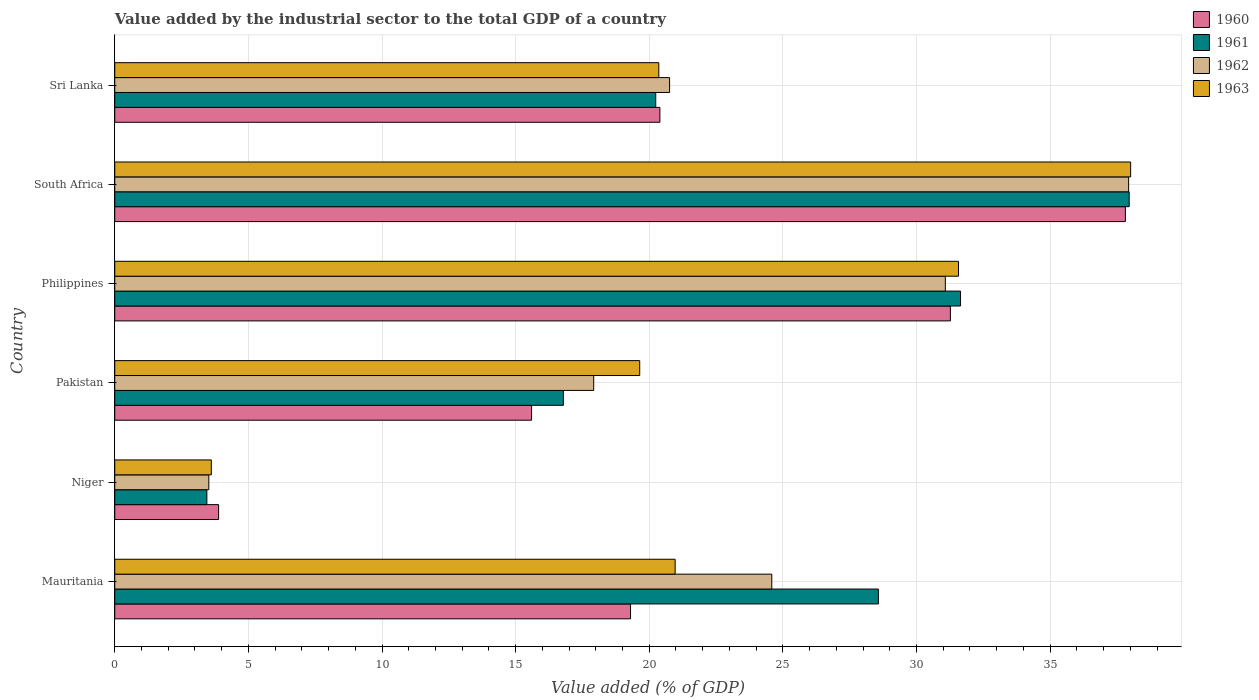How many different coloured bars are there?
Your response must be concise. 4. How many groups of bars are there?
Offer a terse response. 6. Are the number of bars on each tick of the Y-axis equal?
Offer a terse response. Yes. What is the label of the 2nd group of bars from the top?
Make the answer very short. South Africa. In how many cases, is the number of bars for a given country not equal to the number of legend labels?
Your answer should be compact. 0. What is the value added by the industrial sector to the total GDP in 1962 in Pakistan?
Provide a succinct answer. 17.92. Across all countries, what is the maximum value added by the industrial sector to the total GDP in 1963?
Offer a very short reply. 38.01. Across all countries, what is the minimum value added by the industrial sector to the total GDP in 1962?
Keep it short and to the point. 3.52. In which country was the value added by the industrial sector to the total GDP in 1960 maximum?
Offer a terse response. South Africa. In which country was the value added by the industrial sector to the total GDP in 1960 minimum?
Offer a very short reply. Niger. What is the total value added by the industrial sector to the total GDP in 1963 in the graph?
Give a very brief answer. 134.17. What is the difference between the value added by the industrial sector to the total GDP in 1963 in Mauritania and that in Philippines?
Offer a terse response. -10.6. What is the difference between the value added by the industrial sector to the total GDP in 1962 in Mauritania and the value added by the industrial sector to the total GDP in 1960 in Pakistan?
Your response must be concise. 8.99. What is the average value added by the industrial sector to the total GDP in 1961 per country?
Your answer should be compact. 23.11. What is the difference between the value added by the industrial sector to the total GDP in 1960 and value added by the industrial sector to the total GDP in 1962 in Mauritania?
Keep it short and to the point. -5.29. What is the ratio of the value added by the industrial sector to the total GDP in 1960 in Niger to that in South Africa?
Your answer should be compact. 0.1. Is the difference between the value added by the industrial sector to the total GDP in 1960 in Niger and Sri Lanka greater than the difference between the value added by the industrial sector to the total GDP in 1962 in Niger and Sri Lanka?
Provide a succinct answer. Yes. What is the difference between the highest and the second highest value added by the industrial sector to the total GDP in 1960?
Offer a very short reply. 6.55. What is the difference between the highest and the lowest value added by the industrial sector to the total GDP in 1960?
Your answer should be very brief. 33.93. What does the 1st bar from the top in Philippines represents?
Make the answer very short. 1963. What does the 2nd bar from the bottom in South Africa represents?
Ensure brevity in your answer.  1961. Is it the case that in every country, the sum of the value added by the industrial sector to the total GDP in 1960 and value added by the industrial sector to the total GDP in 1962 is greater than the value added by the industrial sector to the total GDP in 1961?
Offer a terse response. Yes. How many bars are there?
Make the answer very short. 24. What is the difference between two consecutive major ticks on the X-axis?
Provide a succinct answer. 5. Does the graph contain any zero values?
Give a very brief answer. No. Where does the legend appear in the graph?
Keep it short and to the point. Top right. How many legend labels are there?
Your answer should be compact. 4. How are the legend labels stacked?
Your answer should be very brief. Vertical. What is the title of the graph?
Offer a terse response. Value added by the industrial sector to the total GDP of a country. What is the label or title of the X-axis?
Your answer should be very brief. Value added (% of GDP). What is the label or title of the Y-axis?
Your response must be concise. Country. What is the Value added (% of GDP) of 1960 in Mauritania?
Provide a short and direct response. 19.3. What is the Value added (% of GDP) in 1961 in Mauritania?
Your answer should be compact. 28.57. What is the Value added (% of GDP) of 1962 in Mauritania?
Make the answer very short. 24.59. What is the Value added (% of GDP) in 1963 in Mauritania?
Keep it short and to the point. 20.97. What is the Value added (% of GDP) of 1960 in Niger?
Make the answer very short. 3.89. What is the Value added (% of GDP) of 1961 in Niger?
Provide a succinct answer. 3.45. What is the Value added (% of GDP) in 1962 in Niger?
Keep it short and to the point. 3.52. What is the Value added (% of GDP) in 1963 in Niger?
Ensure brevity in your answer.  3.61. What is the Value added (% of GDP) of 1960 in Pakistan?
Provide a short and direct response. 15.6. What is the Value added (% of GDP) in 1961 in Pakistan?
Your answer should be very brief. 16.79. What is the Value added (% of GDP) in 1962 in Pakistan?
Your answer should be very brief. 17.92. What is the Value added (% of GDP) of 1963 in Pakistan?
Your answer should be compact. 19.64. What is the Value added (% of GDP) of 1960 in Philippines?
Your answer should be compact. 31.27. What is the Value added (% of GDP) in 1961 in Philippines?
Provide a short and direct response. 31.65. What is the Value added (% of GDP) in 1962 in Philippines?
Your answer should be very brief. 31.08. What is the Value added (% of GDP) of 1963 in Philippines?
Your answer should be compact. 31.57. What is the Value added (% of GDP) in 1960 in South Africa?
Offer a terse response. 37.82. What is the Value added (% of GDP) of 1961 in South Africa?
Ensure brevity in your answer.  37.96. What is the Value added (% of GDP) in 1962 in South Africa?
Provide a short and direct response. 37.94. What is the Value added (% of GDP) in 1963 in South Africa?
Provide a short and direct response. 38.01. What is the Value added (% of GDP) of 1960 in Sri Lanka?
Ensure brevity in your answer.  20.4. What is the Value added (% of GDP) in 1961 in Sri Lanka?
Provide a succinct answer. 20.24. What is the Value added (% of GDP) of 1962 in Sri Lanka?
Your answer should be very brief. 20.76. What is the Value added (% of GDP) of 1963 in Sri Lanka?
Make the answer very short. 20.36. Across all countries, what is the maximum Value added (% of GDP) of 1960?
Offer a very short reply. 37.82. Across all countries, what is the maximum Value added (% of GDP) of 1961?
Keep it short and to the point. 37.96. Across all countries, what is the maximum Value added (% of GDP) in 1962?
Your answer should be very brief. 37.94. Across all countries, what is the maximum Value added (% of GDP) in 1963?
Provide a short and direct response. 38.01. Across all countries, what is the minimum Value added (% of GDP) of 1960?
Your response must be concise. 3.89. Across all countries, what is the minimum Value added (% of GDP) of 1961?
Your response must be concise. 3.45. Across all countries, what is the minimum Value added (% of GDP) in 1962?
Ensure brevity in your answer.  3.52. Across all countries, what is the minimum Value added (% of GDP) of 1963?
Your answer should be very brief. 3.61. What is the total Value added (% of GDP) in 1960 in the graph?
Offer a very short reply. 128.27. What is the total Value added (% of GDP) in 1961 in the graph?
Offer a very short reply. 138.66. What is the total Value added (% of GDP) in 1962 in the graph?
Offer a terse response. 135.81. What is the total Value added (% of GDP) in 1963 in the graph?
Your response must be concise. 134.17. What is the difference between the Value added (% of GDP) of 1960 in Mauritania and that in Niger?
Offer a terse response. 15.41. What is the difference between the Value added (% of GDP) in 1961 in Mauritania and that in Niger?
Provide a short and direct response. 25.13. What is the difference between the Value added (% of GDP) of 1962 in Mauritania and that in Niger?
Make the answer very short. 21.07. What is the difference between the Value added (% of GDP) of 1963 in Mauritania and that in Niger?
Make the answer very short. 17.36. What is the difference between the Value added (% of GDP) in 1960 in Mauritania and that in Pakistan?
Your answer should be compact. 3.7. What is the difference between the Value added (% of GDP) of 1961 in Mauritania and that in Pakistan?
Ensure brevity in your answer.  11.79. What is the difference between the Value added (% of GDP) of 1962 in Mauritania and that in Pakistan?
Your response must be concise. 6.66. What is the difference between the Value added (% of GDP) in 1963 in Mauritania and that in Pakistan?
Provide a succinct answer. 1.33. What is the difference between the Value added (% of GDP) in 1960 in Mauritania and that in Philippines?
Offer a very short reply. -11.97. What is the difference between the Value added (% of GDP) in 1961 in Mauritania and that in Philippines?
Give a very brief answer. -3.07. What is the difference between the Value added (% of GDP) in 1962 in Mauritania and that in Philippines?
Your answer should be very brief. -6.49. What is the difference between the Value added (% of GDP) of 1963 in Mauritania and that in Philippines?
Your response must be concise. -10.6. What is the difference between the Value added (% of GDP) of 1960 in Mauritania and that in South Africa?
Make the answer very short. -18.52. What is the difference between the Value added (% of GDP) in 1961 in Mauritania and that in South Africa?
Offer a very short reply. -9.38. What is the difference between the Value added (% of GDP) of 1962 in Mauritania and that in South Africa?
Your answer should be compact. -13.35. What is the difference between the Value added (% of GDP) in 1963 in Mauritania and that in South Africa?
Offer a very short reply. -17.04. What is the difference between the Value added (% of GDP) in 1960 in Mauritania and that in Sri Lanka?
Your answer should be compact. -1.1. What is the difference between the Value added (% of GDP) in 1961 in Mauritania and that in Sri Lanka?
Your answer should be compact. 8.33. What is the difference between the Value added (% of GDP) in 1962 in Mauritania and that in Sri Lanka?
Your answer should be compact. 3.82. What is the difference between the Value added (% of GDP) of 1963 in Mauritania and that in Sri Lanka?
Your response must be concise. 0.61. What is the difference between the Value added (% of GDP) in 1960 in Niger and that in Pakistan?
Ensure brevity in your answer.  -11.71. What is the difference between the Value added (% of GDP) of 1961 in Niger and that in Pakistan?
Offer a terse response. -13.34. What is the difference between the Value added (% of GDP) in 1962 in Niger and that in Pakistan?
Your answer should be very brief. -14.4. What is the difference between the Value added (% of GDP) in 1963 in Niger and that in Pakistan?
Give a very brief answer. -16.03. What is the difference between the Value added (% of GDP) in 1960 in Niger and that in Philippines?
Keep it short and to the point. -27.38. What is the difference between the Value added (% of GDP) in 1961 in Niger and that in Philippines?
Offer a very short reply. -28.2. What is the difference between the Value added (% of GDP) in 1962 in Niger and that in Philippines?
Offer a terse response. -27.56. What is the difference between the Value added (% of GDP) in 1963 in Niger and that in Philippines?
Make the answer very short. -27.96. What is the difference between the Value added (% of GDP) of 1960 in Niger and that in South Africa?
Provide a short and direct response. -33.93. What is the difference between the Value added (% of GDP) of 1961 in Niger and that in South Africa?
Make the answer very short. -34.51. What is the difference between the Value added (% of GDP) in 1962 in Niger and that in South Africa?
Ensure brevity in your answer.  -34.42. What is the difference between the Value added (% of GDP) of 1963 in Niger and that in South Africa?
Your answer should be very brief. -34.4. What is the difference between the Value added (% of GDP) in 1960 in Niger and that in Sri Lanka?
Offer a very short reply. -16.51. What is the difference between the Value added (% of GDP) in 1961 in Niger and that in Sri Lanka?
Ensure brevity in your answer.  -16.8. What is the difference between the Value added (% of GDP) of 1962 in Niger and that in Sri Lanka?
Offer a terse response. -17.24. What is the difference between the Value added (% of GDP) in 1963 in Niger and that in Sri Lanka?
Offer a terse response. -16.74. What is the difference between the Value added (% of GDP) of 1960 in Pakistan and that in Philippines?
Your response must be concise. -15.67. What is the difference between the Value added (% of GDP) of 1961 in Pakistan and that in Philippines?
Provide a short and direct response. -14.86. What is the difference between the Value added (% of GDP) of 1962 in Pakistan and that in Philippines?
Make the answer very short. -13.16. What is the difference between the Value added (% of GDP) in 1963 in Pakistan and that in Philippines?
Ensure brevity in your answer.  -11.93. What is the difference between the Value added (% of GDP) of 1960 in Pakistan and that in South Africa?
Provide a short and direct response. -22.22. What is the difference between the Value added (% of GDP) of 1961 in Pakistan and that in South Africa?
Your response must be concise. -21.17. What is the difference between the Value added (% of GDP) in 1962 in Pakistan and that in South Africa?
Make the answer very short. -20.02. What is the difference between the Value added (% of GDP) in 1963 in Pakistan and that in South Africa?
Your answer should be very brief. -18.37. What is the difference between the Value added (% of GDP) of 1960 in Pakistan and that in Sri Lanka?
Provide a short and direct response. -4.8. What is the difference between the Value added (% of GDP) in 1961 in Pakistan and that in Sri Lanka?
Offer a terse response. -3.46. What is the difference between the Value added (% of GDP) in 1962 in Pakistan and that in Sri Lanka?
Make the answer very short. -2.84. What is the difference between the Value added (% of GDP) of 1963 in Pakistan and that in Sri Lanka?
Your answer should be very brief. -0.71. What is the difference between the Value added (% of GDP) in 1960 in Philippines and that in South Africa?
Provide a succinct answer. -6.55. What is the difference between the Value added (% of GDP) of 1961 in Philippines and that in South Africa?
Your answer should be very brief. -6.31. What is the difference between the Value added (% of GDP) of 1962 in Philippines and that in South Africa?
Give a very brief answer. -6.86. What is the difference between the Value added (% of GDP) of 1963 in Philippines and that in South Africa?
Provide a short and direct response. -6.44. What is the difference between the Value added (% of GDP) of 1960 in Philippines and that in Sri Lanka?
Keep it short and to the point. 10.87. What is the difference between the Value added (% of GDP) in 1961 in Philippines and that in Sri Lanka?
Give a very brief answer. 11.41. What is the difference between the Value added (% of GDP) in 1962 in Philippines and that in Sri Lanka?
Offer a very short reply. 10.32. What is the difference between the Value added (% of GDP) of 1963 in Philippines and that in Sri Lanka?
Make the answer very short. 11.22. What is the difference between the Value added (% of GDP) of 1960 in South Africa and that in Sri Lanka?
Make the answer very short. 17.42. What is the difference between the Value added (% of GDP) in 1961 in South Africa and that in Sri Lanka?
Provide a succinct answer. 17.72. What is the difference between the Value added (% of GDP) of 1962 in South Africa and that in Sri Lanka?
Your answer should be very brief. 17.18. What is the difference between the Value added (% of GDP) in 1963 in South Africa and that in Sri Lanka?
Your response must be concise. 17.66. What is the difference between the Value added (% of GDP) in 1960 in Mauritania and the Value added (% of GDP) in 1961 in Niger?
Give a very brief answer. 15.85. What is the difference between the Value added (% of GDP) of 1960 in Mauritania and the Value added (% of GDP) of 1962 in Niger?
Offer a terse response. 15.78. What is the difference between the Value added (% of GDP) in 1960 in Mauritania and the Value added (% of GDP) in 1963 in Niger?
Your answer should be compact. 15.69. What is the difference between the Value added (% of GDP) of 1961 in Mauritania and the Value added (% of GDP) of 1962 in Niger?
Keep it short and to the point. 25.05. What is the difference between the Value added (% of GDP) of 1961 in Mauritania and the Value added (% of GDP) of 1963 in Niger?
Give a very brief answer. 24.96. What is the difference between the Value added (% of GDP) in 1962 in Mauritania and the Value added (% of GDP) in 1963 in Niger?
Your answer should be compact. 20.97. What is the difference between the Value added (% of GDP) in 1960 in Mauritania and the Value added (% of GDP) in 1961 in Pakistan?
Your response must be concise. 2.51. What is the difference between the Value added (% of GDP) in 1960 in Mauritania and the Value added (% of GDP) in 1962 in Pakistan?
Offer a terse response. 1.38. What is the difference between the Value added (% of GDP) of 1960 in Mauritania and the Value added (% of GDP) of 1963 in Pakistan?
Make the answer very short. -0.34. What is the difference between the Value added (% of GDP) of 1961 in Mauritania and the Value added (% of GDP) of 1962 in Pakistan?
Your answer should be very brief. 10.65. What is the difference between the Value added (% of GDP) in 1961 in Mauritania and the Value added (% of GDP) in 1963 in Pakistan?
Your answer should be compact. 8.93. What is the difference between the Value added (% of GDP) in 1962 in Mauritania and the Value added (% of GDP) in 1963 in Pakistan?
Your response must be concise. 4.94. What is the difference between the Value added (% of GDP) in 1960 in Mauritania and the Value added (% of GDP) in 1961 in Philippines?
Give a very brief answer. -12.35. What is the difference between the Value added (% of GDP) in 1960 in Mauritania and the Value added (% of GDP) in 1962 in Philippines?
Provide a succinct answer. -11.78. What is the difference between the Value added (% of GDP) of 1960 in Mauritania and the Value added (% of GDP) of 1963 in Philippines?
Make the answer very short. -12.27. What is the difference between the Value added (% of GDP) of 1961 in Mauritania and the Value added (% of GDP) of 1962 in Philippines?
Give a very brief answer. -2.51. What is the difference between the Value added (% of GDP) in 1961 in Mauritania and the Value added (% of GDP) in 1963 in Philippines?
Make the answer very short. -3. What is the difference between the Value added (% of GDP) in 1962 in Mauritania and the Value added (% of GDP) in 1963 in Philippines?
Your response must be concise. -6.99. What is the difference between the Value added (% of GDP) of 1960 in Mauritania and the Value added (% of GDP) of 1961 in South Africa?
Provide a succinct answer. -18.66. What is the difference between the Value added (% of GDP) in 1960 in Mauritania and the Value added (% of GDP) in 1962 in South Africa?
Your response must be concise. -18.64. What is the difference between the Value added (% of GDP) of 1960 in Mauritania and the Value added (% of GDP) of 1963 in South Africa?
Give a very brief answer. -18.71. What is the difference between the Value added (% of GDP) of 1961 in Mauritania and the Value added (% of GDP) of 1962 in South Africa?
Offer a very short reply. -9.36. What is the difference between the Value added (% of GDP) of 1961 in Mauritania and the Value added (% of GDP) of 1963 in South Africa?
Offer a terse response. -9.44. What is the difference between the Value added (% of GDP) in 1962 in Mauritania and the Value added (% of GDP) in 1963 in South Africa?
Your answer should be very brief. -13.43. What is the difference between the Value added (% of GDP) of 1960 in Mauritania and the Value added (% of GDP) of 1961 in Sri Lanka?
Your response must be concise. -0.94. What is the difference between the Value added (% of GDP) of 1960 in Mauritania and the Value added (% of GDP) of 1962 in Sri Lanka?
Make the answer very short. -1.46. What is the difference between the Value added (% of GDP) in 1960 in Mauritania and the Value added (% of GDP) in 1963 in Sri Lanka?
Give a very brief answer. -1.06. What is the difference between the Value added (% of GDP) in 1961 in Mauritania and the Value added (% of GDP) in 1962 in Sri Lanka?
Your response must be concise. 7.81. What is the difference between the Value added (% of GDP) of 1961 in Mauritania and the Value added (% of GDP) of 1963 in Sri Lanka?
Your response must be concise. 8.22. What is the difference between the Value added (% of GDP) in 1962 in Mauritania and the Value added (% of GDP) in 1963 in Sri Lanka?
Give a very brief answer. 4.23. What is the difference between the Value added (% of GDP) in 1960 in Niger and the Value added (% of GDP) in 1961 in Pakistan?
Keep it short and to the point. -12.9. What is the difference between the Value added (% of GDP) of 1960 in Niger and the Value added (% of GDP) of 1962 in Pakistan?
Your answer should be very brief. -14.04. What is the difference between the Value added (% of GDP) in 1960 in Niger and the Value added (% of GDP) in 1963 in Pakistan?
Give a very brief answer. -15.76. What is the difference between the Value added (% of GDP) in 1961 in Niger and the Value added (% of GDP) in 1962 in Pakistan?
Provide a short and direct response. -14.48. What is the difference between the Value added (% of GDP) in 1961 in Niger and the Value added (% of GDP) in 1963 in Pakistan?
Ensure brevity in your answer.  -16.2. What is the difference between the Value added (% of GDP) in 1962 in Niger and the Value added (% of GDP) in 1963 in Pakistan?
Offer a very short reply. -16.12. What is the difference between the Value added (% of GDP) of 1960 in Niger and the Value added (% of GDP) of 1961 in Philippines?
Your response must be concise. -27.76. What is the difference between the Value added (% of GDP) in 1960 in Niger and the Value added (% of GDP) in 1962 in Philippines?
Give a very brief answer. -27.19. What is the difference between the Value added (% of GDP) of 1960 in Niger and the Value added (% of GDP) of 1963 in Philippines?
Ensure brevity in your answer.  -27.69. What is the difference between the Value added (% of GDP) in 1961 in Niger and the Value added (% of GDP) in 1962 in Philippines?
Your answer should be very brief. -27.63. What is the difference between the Value added (% of GDP) in 1961 in Niger and the Value added (% of GDP) in 1963 in Philippines?
Offer a terse response. -28.13. What is the difference between the Value added (% of GDP) of 1962 in Niger and the Value added (% of GDP) of 1963 in Philippines?
Ensure brevity in your answer.  -28.05. What is the difference between the Value added (% of GDP) of 1960 in Niger and the Value added (% of GDP) of 1961 in South Africa?
Give a very brief answer. -34.07. What is the difference between the Value added (% of GDP) of 1960 in Niger and the Value added (% of GDP) of 1962 in South Africa?
Offer a terse response. -34.05. What is the difference between the Value added (% of GDP) in 1960 in Niger and the Value added (% of GDP) in 1963 in South Africa?
Provide a short and direct response. -34.13. What is the difference between the Value added (% of GDP) in 1961 in Niger and the Value added (% of GDP) in 1962 in South Africa?
Provide a short and direct response. -34.49. What is the difference between the Value added (% of GDP) of 1961 in Niger and the Value added (% of GDP) of 1963 in South Africa?
Offer a very short reply. -34.57. What is the difference between the Value added (% of GDP) in 1962 in Niger and the Value added (% of GDP) in 1963 in South Africa?
Keep it short and to the point. -34.49. What is the difference between the Value added (% of GDP) in 1960 in Niger and the Value added (% of GDP) in 1961 in Sri Lanka?
Ensure brevity in your answer.  -16.36. What is the difference between the Value added (% of GDP) in 1960 in Niger and the Value added (% of GDP) in 1962 in Sri Lanka?
Keep it short and to the point. -16.88. What is the difference between the Value added (% of GDP) of 1960 in Niger and the Value added (% of GDP) of 1963 in Sri Lanka?
Ensure brevity in your answer.  -16.47. What is the difference between the Value added (% of GDP) of 1961 in Niger and the Value added (% of GDP) of 1962 in Sri Lanka?
Keep it short and to the point. -17.32. What is the difference between the Value added (% of GDP) of 1961 in Niger and the Value added (% of GDP) of 1963 in Sri Lanka?
Offer a very short reply. -16.91. What is the difference between the Value added (% of GDP) of 1962 in Niger and the Value added (% of GDP) of 1963 in Sri Lanka?
Your response must be concise. -16.84. What is the difference between the Value added (% of GDP) of 1960 in Pakistan and the Value added (% of GDP) of 1961 in Philippines?
Provide a succinct answer. -16.05. What is the difference between the Value added (% of GDP) of 1960 in Pakistan and the Value added (% of GDP) of 1962 in Philippines?
Provide a succinct answer. -15.48. What is the difference between the Value added (% of GDP) of 1960 in Pakistan and the Value added (% of GDP) of 1963 in Philippines?
Give a very brief answer. -15.98. What is the difference between the Value added (% of GDP) of 1961 in Pakistan and the Value added (% of GDP) of 1962 in Philippines?
Offer a very short reply. -14.29. What is the difference between the Value added (% of GDP) in 1961 in Pakistan and the Value added (% of GDP) in 1963 in Philippines?
Provide a short and direct response. -14.79. What is the difference between the Value added (% of GDP) of 1962 in Pakistan and the Value added (% of GDP) of 1963 in Philippines?
Make the answer very short. -13.65. What is the difference between the Value added (% of GDP) of 1960 in Pakistan and the Value added (% of GDP) of 1961 in South Africa?
Make the answer very short. -22.36. What is the difference between the Value added (% of GDP) of 1960 in Pakistan and the Value added (% of GDP) of 1962 in South Africa?
Make the answer very short. -22.34. What is the difference between the Value added (% of GDP) of 1960 in Pakistan and the Value added (% of GDP) of 1963 in South Africa?
Offer a terse response. -22.42. What is the difference between the Value added (% of GDP) in 1961 in Pakistan and the Value added (% of GDP) in 1962 in South Africa?
Provide a short and direct response. -21.15. What is the difference between the Value added (% of GDP) in 1961 in Pakistan and the Value added (% of GDP) in 1963 in South Africa?
Your answer should be very brief. -21.23. What is the difference between the Value added (% of GDP) in 1962 in Pakistan and the Value added (% of GDP) in 1963 in South Africa?
Your answer should be very brief. -20.09. What is the difference between the Value added (% of GDP) of 1960 in Pakistan and the Value added (% of GDP) of 1961 in Sri Lanka?
Keep it short and to the point. -4.65. What is the difference between the Value added (% of GDP) in 1960 in Pakistan and the Value added (% of GDP) in 1962 in Sri Lanka?
Your answer should be compact. -5.16. What is the difference between the Value added (% of GDP) of 1960 in Pakistan and the Value added (% of GDP) of 1963 in Sri Lanka?
Your answer should be very brief. -4.76. What is the difference between the Value added (% of GDP) in 1961 in Pakistan and the Value added (% of GDP) in 1962 in Sri Lanka?
Keep it short and to the point. -3.97. What is the difference between the Value added (% of GDP) in 1961 in Pakistan and the Value added (% of GDP) in 1963 in Sri Lanka?
Make the answer very short. -3.57. What is the difference between the Value added (% of GDP) of 1962 in Pakistan and the Value added (% of GDP) of 1963 in Sri Lanka?
Your answer should be very brief. -2.44. What is the difference between the Value added (% of GDP) in 1960 in Philippines and the Value added (% of GDP) in 1961 in South Africa?
Provide a succinct answer. -6.69. What is the difference between the Value added (% of GDP) in 1960 in Philippines and the Value added (% of GDP) in 1962 in South Africa?
Offer a terse response. -6.67. What is the difference between the Value added (% of GDP) in 1960 in Philippines and the Value added (% of GDP) in 1963 in South Africa?
Your answer should be compact. -6.75. What is the difference between the Value added (% of GDP) of 1961 in Philippines and the Value added (% of GDP) of 1962 in South Africa?
Your response must be concise. -6.29. What is the difference between the Value added (% of GDP) in 1961 in Philippines and the Value added (% of GDP) in 1963 in South Africa?
Your answer should be very brief. -6.37. What is the difference between the Value added (% of GDP) of 1962 in Philippines and the Value added (% of GDP) of 1963 in South Africa?
Your response must be concise. -6.93. What is the difference between the Value added (% of GDP) of 1960 in Philippines and the Value added (% of GDP) of 1961 in Sri Lanka?
Your answer should be compact. 11.03. What is the difference between the Value added (% of GDP) of 1960 in Philippines and the Value added (% of GDP) of 1962 in Sri Lanka?
Give a very brief answer. 10.51. What is the difference between the Value added (% of GDP) of 1960 in Philippines and the Value added (% of GDP) of 1963 in Sri Lanka?
Offer a very short reply. 10.91. What is the difference between the Value added (% of GDP) in 1961 in Philippines and the Value added (% of GDP) in 1962 in Sri Lanka?
Your response must be concise. 10.89. What is the difference between the Value added (% of GDP) of 1961 in Philippines and the Value added (% of GDP) of 1963 in Sri Lanka?
Offer a very short reply. 11.29. What is the difference between the Value added (% of GDP) of 1962 in Philippines and the Value added (% of GDP) of 1963 in Sri Lanka?
Your answer should be compact. 10.72. What is the difference between the Value added (% of GDP) of 1960 in South Africa and the Value added (% of GDP) of 1961 in Sri Lanka?
Provide a short and direct response. 17.57. What is the difference between the Value added (% of GDP) of 1960 in South Africa and the Value added (% of GDP) of 1962 in Sri Lanka?
Offer a terse response. 17.06. What is the difference between the Value added (% of GDP) of 1960 in South Africa and the Value added (% of GDP) of 1963 in Sri Lanka?
Your response must be concise. 17.46. What is the difference between the Value added (% of GDP) of 1961 in South Africa and the Value added (% of GDP) of 1962 in Sri Lanka?
Give a very brief answer. 17.2. What is the difference between the Value added (% of GDP) of 1961 in South Africa and the Value added (% of GDP) of 1963 in Sri Lanka?
Keep it short and to the point. 17.6. What is the difference between the Value added (% of GDP) of 1962 in South Africa and the Value added (% of GDP) of 1963 in Sri Lanka?
Provide a succinct answer. 17.58. What is the average Value added (% of GDP) in 1960 per country?
Provide a succinct answer. 21.38. What is the average Value added (% of GDP) in 1961 per country?
Offer a terse response. 23.11. What is the average Value added (% of GDP) of 1962 per country?
Provide a succinct answer. 22.63. What is the average Value added (% of GDP) in 1963 per country?
Give a very brief answer. 22.36. What is the difference between the Value added (% of GDP) of 1960 and Value added (% of GDP) of 1961 in Mauritania?
Ensure brevity in your answer.  -9.27. What is the difference between the Value added (% of GDP) of 1960 and Value added (% of GDP) of 1962 in Mauritania?
Offer a terse response. -5.29. What is the difference between the Value added (% of GDP) in 1960 and Value added (% of GDP) in 1963 in Mauritania?
Ensure brevity in your answer.  -1.67. What is the difference between the Value added (% of GDP) of 1961 and Value added (% of GDP) of 1962 in Mauritania?
Make the answer very short. 3.99. What is the difference between the Value added (% of GDP) in 1961 and Value added (% of GDP) in 1963 in Mauritania?
Give a very brief answer. 7.6. What is the difference between the Value added (% of GDP) of 1962 and Value added (% of GDP) of 1963 in Mauritania?
Provide a succinct answer. 3.62. What is the difference between the Value added (% of GDP) of 1960 and Value added (% of GDP) of 1961 in Niger?
Your response must be concise. 0.44. What is the difference between the Value added (% of GDP) in 1960 and Value added (% of GDP) in 1962 in Niger?
Make the answer very short. 0.37. What is the difference between the Value added (% of GDP) in 1960 and Value added (% of GDP) in 1963 in Niger?
Your response must be concise. 0.27. What is the difference between the Value added (% of GDP) of 1961 and Value added (% of GDP) of 1962 in Niger?
Provide a succinct answer. -0.07. What is the difference between the Value added (% of GDP) in 1961 and Value added (% of GDP) in 1963 in Niger?
Provide a short and direct response. -0.17. What is the difference between the Value added (% of GDP) of 1962 and Value added (% of GDP) of 1963 in Niger?
Your answer should be very brief. -0.09. What is the difference between the Value added (% of GDP) in 1960 and Value added (% of GDP) in 1961 in Pakistan?
Give a very brief answer. -1.19. What is the difference between the Value added (% of GDP) in 1960 and Value added (% of GDP) in 1962 in Pakistan?
Ensure brevity in your answer.  -2.33. What is the difference between the Value added (% of GDP) of 1960 and Value added (% of GDP) of 1963 in Pakistan?
Ensure brevity in your answer.  -4.05. What is the difference between the Value added (% of GDP) of 1961 and Value added (% of GDP) of 1962 in Pakistan?
Offer a terse response. -1.14. What is the difference between the Value added (% of GDP) of 1961 and Value added (% of GDP) of 1963 in Pakistan?
Your answer should be compact. -2.86. What is the difference between the Value added (% of GDP) in 1962 and Value added (% of GDP) in 1963 in Pakistan?
Provide a short and direct response. -1.72. What is the difference between the Value added (% of GDP) of 1960 and Value added (% of GDP) of 1961 in Philippines?
Provide a short and direct response. -0.38. What is the difference between the Value added (% of GDP) in 1960 and Value added (% of GDP) in 1962 in Philippines?
Provide a succinct answer. 0.19. What is the difference between the Value added (% of GDP) of 1960 and Value added (% of GDP) of 1963 in Philippines?
Offer a terse response. -0.3. What is the difference between the Value added (% of GDP) in 1961 and Value added (% of GDP) in 1962 in Philippines?
Make the answer very short. 0.57. What is the difference between the Value added (% of GDP) in 1961 and Value added (% of GDP) in 1963 in Philippines?
Your answer should be very brief. 0.08. What is the difference between the Value added (% of GDP) of 1962 and Value added (% of GDP) of 1963 in Philippines?
Ensure brevity in your answer.  -0.49. What is the difference between the Value added (% of GDP) in 1960 and Value added (% of GDP) in 1961 in South Africa?
Provide a short and direct response. -0.14. What is the difference between the Value added (% of GDP) in 1960 and Value added (% of GDP) in 1962 in South Africa?
Make the answer very short. -0.12. What is the difference between the Value added (% of GDP) of 1960 and Value added (% of GDP) of 1963 in South Africa?
Your response must be concise. -0.2. What is the difference between the Value added (% of GDP) in 1961 and Value added (% of GDP) in 1962 in South Africa?
Keep it short and to the point. 0.02. What is the difference between the Value added (% of GDP) in 1961 and Value added (% of GDP) in 1963 in South Africa?
Keep it short and to the point. -0.05. What is the difference between the Value added (% of GDP) of 1962 and Value added (% of GDP) of 1963 in South Africa?
Your answer should be very brief. -0.08. What is the difference between the Value added (% of GDP) of 1960 and Value added (% of GDP) of 1961 in Sri Lanka?
Keep it short and to the point. 0.16. What is the difference between the Value added (% of GDP) of 1960 and Value added (% of GDP) of 1962 in Sri Lanka?
Offer a very short reply. -0.36. What is the difference between the Value added (% of GDP) of 1960 and Value added (% of GDP) of 1963 in Sri Lanka?
Your answer should be very brief. 0.04. What is the difference between the Value added (% of GDP) in 1961 and Value added (% of GDP) in 1962 in Sri Lanka?
Keep it short and to the point. -0.52. What is the difference between the Value added (% of GDP) in 1961 and Value added (% of GDP) in 1963 in Sri Lanka?
Your answer should be very brief. -0.11. What is the difference between the Value added (% of GDP) of 1962 and Value added (% of GDP) of 1963 in Sri Lanka?
Offer a terse response. 0.4. What is the ratio of the Value added (% of GDP) in 1960 in Mauritania to that in Niger?
Make the answer very short. 4.97. What is the ratio of the Value added (% of GDP) of 1961 in Mauritania to that in Niger?
Provide a short and direct response. 8.29. What is the ratio of the Value added (% of GDP) in 1962 in Mauritania to that in Niger?
Make the answer very short. 6.99. What is the ratio of the Value added (% of GDP) in 1963 in Mauritania to that in Niger?
Provide a succinct answer. 5.8. What is the ratio of the Value added (% of GDP) of 1960 in Mauritania to that in Pakistan?
Offer a terse response. 1.24. What is the ratio of the Value added (% of GDP) of 1961 in Mauritania to that in Pakistan?
Give a very brief answer. 1.7. What is the ratio of the Value added (% of GDP) of 1962 in Mauritania to that in Pakistan?
Give a very brief answer. 1.37. What is the ratio of the Value added (% of GDP) of 1963 in Mauritania to that in Pakistan?
Give a very brief answer. 1.07. What is the ratio of the Value added (% of GDP) in 1960 in Mauritania to that in Philippines?
Ensure brevity in your answer.  0.62. What is the ratio of the Value added (% of GDP) in 1961 in Mauritania to that in Philippines?
Offer a very short reply. 0.9. What is the ratio of the Value added (% of GDP) in 1962 in Mauritania to that in Philippines?
Your answer should be compact. 0.79. What is the ratio of the Value added (% of GDP) in 1963 in Mauritania to that in Philippines?
Keep it short and to the point. 0.66. What is the ratio of the Value added (% of GDP) in 1960 in Mauritania to that in South Africa?
Provide a short and direct response. 0.51. What is the ratio of the Value added (% of GDP) in 1961 in Mauritania to that in South Africa?
Provide a short and direct response. 0.75. What is the ratio of the Value added (% of GDP) in 1962 in Mauritania to that in South Africa?
Your response must be concise. 0.65. What is the ratio of the Value added (% of GDP) of 1963 in Mauritania to that in South Africa?
Keep it short and to the point. 0.55. What is the ratio of the Value added (% of GDP) in 1960 in Mauritania to that in Sri Lanka?
Give a very brief answer. 0.95. What is the ratio of the Value added (% of GDP) of 1961 in Mauritania to that in Sri Lanka?
Provide a short and direct response. 1.41. What is the ratio of the Value added (% of GDP) in 1962 in Mauritania to that in Sri Lanka?
Your answer should be very brief. 1.18. What is the ratio of the Value added (% of GDP) in 1963 in Mauritania to that in Sri Lanka?
Offer a terse response. 1.03. What is the ratio of the Value added (% of GDP) of 1960 in Niger to that in Pakistan?
Provide a succinct answer. 0.25. What is the ratio of the Value added (% of GDP) in 1961 in Niger to that in Pakistan?
Provide a short and direct response. 0.21. What is the ratio of the Value added (% of GDP) in 1962 in Niger to that in Pakistan?
Ensure brevity in your answer.  0.2. What is the ratio of the Value added (% of GDP) of 1963 in Niger to that in Pakistan?
Your answer should be very brief. 0.18. What is the ratio of the Value added (% of GDP) of 1960 in Niger to that in Philippines?
Offer a very short reply. 0.12. What is the ratio of the Value added (% of GDP) in 1961 in Niger to that in Philippines?
Offer a very short reply. 0.11. What is the ratio of the Value added (% of GDP) in 1962 in Niger to that in Philippines?
Ensure brevity in your answer.  0.11. What is the ratio of the Value added (% of GDP) of 1963 in Niger to that in Philippines?
Offer a terse response. 0.11. What is the ratio of the Value added (% of GDP) of 1960 in Niger to that in South Africa?
Keep it short and to the point. 0.1. What is the ratio of the Value added (% of GDP) of 1961 in Niger to that in South Africa?
Provide a succinct answer. 0.09. What is the ratio of the Value added (% of GDP) of 1962 in Niger to that in South Africa?
Provide a short and direct response. 0.09. What is the ratio of the Value added (% of GDP) in 1963 in Niger to that in South Africa?
Offer a very short reply. 0.1. What is the ratio of the Value added (% of GDP) in 1960 in Niger to that in Sri Lanka?
Give a very brief answer. 0.19. What is the ratio of the Value added (% of GDP) in 1961 in Niger to that in Sri Lanka?
Keep it short and to the point. 0.17. What is the ratio of the Value added (% of GDP) in 1962 in Niger to that in Sri Lanka?
Provide a short and direct response. 0.17. What is the ratio of the Value added (% of GDP) of 1963 in Niger to that in Sri Lanka?
Give a very brief answer. 0.18. What is the ratio of the Value added (% of GDP) of 1960 in Pakistan to that in Philippines?
Ensure brevity in your answer.  0.5. What is the ratio of the Value added (% of GDP) of 1961 in Pakistan to that in Philippines?
Give a very brief answer. 0.53. What is the ratio of the Value added (% of GDP) of 1962 in Pakistan to that in Philippines?
Your response must be concise. 0.58. What is the ratio of the Value added (% of GDP) in 1963 in Pakistan to that in Philippines?
Give a very brief answer. 0.62. What is the ratio of the Value added (% of GDP) of 1960 in Pakistan to that in South Africa?
Ensure brevity in your answer.  0.41. What is the ratio of the Value added (% of GDP) of 1961 in Pakistan to that in South Africa?
Offer a very short reply. 0.44. What is the ratio of the Value added (% of GDP) in 1962 in Pakistan to that in South Africa?
Ensure brevity in your answer.  0.47. What is the ratio of the Value added (% of GDP) of 1963 in Pakistan to that in South Africa?
Provide a succinct answer. 0.52. What is the ratio of the Value added (% of GDP) in 1960 in Pakistan to that in Sri Lanka?
Your answer should be very brief. 0.76. What is the ratio of the Value added (% of GDP) in 1961 in Pakistan to that in Sri Lanka?
Offer a terse response. 0.83. What is the ratio of the Value added (% of GDP) of 1962 in Pakistan to that in Sri Lanka?
Provide a succinct answer. 0.86. What is the ratio of the Value added (% of GDP) in 1963 in Pakistan to that in Sri Lanka?
Offer a very short reply. 0.96. What is the ratio of the Value added (% of GDP) of 1960 in Philippines to that in South Africa?
Your answer should be very brief. 0.83. What is the ratio of the Value added (% of GDP) of 1961 in Philippines to that in South Africa?
Your answer should be very brief. 0.83. What is the ratio of the Value added (% of GDP) of 1962 in Philippines to that in South Africa?
Offer a terse response. 0.82. What is the ratio of the Value added (% of GDP) in 1963 in Philippines to that in South Africa?
Your answer should be compact. 0.83. What is the ratio of the Value added (% of GDP) in 1960 in Philippines to that in Sri Lanka?
Offer a very short reply. 1.53. What is the ratio of the Value added (% of GDP) in 1961 in Philippines to that in Sri Lanka?
Your answer should be compact. 1.56. What is the ratio of the Value added (% of GDP) of 1962 in Philippines to that in Sri Lanka?
Give a very brief answer. 1.5. What is the ratio of the Value added (% of GDP) in 1963 in Philippines to that in Sri Lanka?
Ensure brevity in your answer.  1.55. What is the ratio of the Value added (% of GDP) of 1960 in South Africa to that in Sri Lanka?
Your response must be concise. 1.85. What is the ratio of the Value added (% of GDP) of 1961 in South Africa to that in Sri Lanka?
Your answer should be compact. 1.88. What is the ratio of the Value added (% of GDP) in 1962 in South Africa to that in Sri Lanka?
Keep it short and to the point. 1.83. What is the ratio of the Value added (% of GDP) of 1963 in South Africa to that in Sri Lanka?
Your answer should be compact. 1.87. What is the difference between the highest and the second highest Value added (% of GDP) of 1960?
Your answer should be compact. 6.55. What is the difference between the highest and the second highest Value added (% of GDP) of 1961?
Offer a very short reply. 6.31. What is the difference between the highest and the second highest Value added (% of GDP) of 1962?
Ensure brevity in your answer.  6.86. What is the difference between the highest and the second highest Value added (% of GDP) of 1963?
Give a very brief answer. 6.44. What is the difference between the highest and the lowest Value added (% of GDP) of 1960?
Offer a very short reply. 33.93. What is the difference between the highest and the lowest Value added (% of GDP) of 1961?
Offer a terse response. 34.51. What is the difference between the highest and the lowest Value added (% of GDP) of 1962?
Your response must be concise. 34.42. What is the difference between the highest and the lowest Value added (% of GDP) in 1963?
Ensure brevity in your answer.  34.4. 